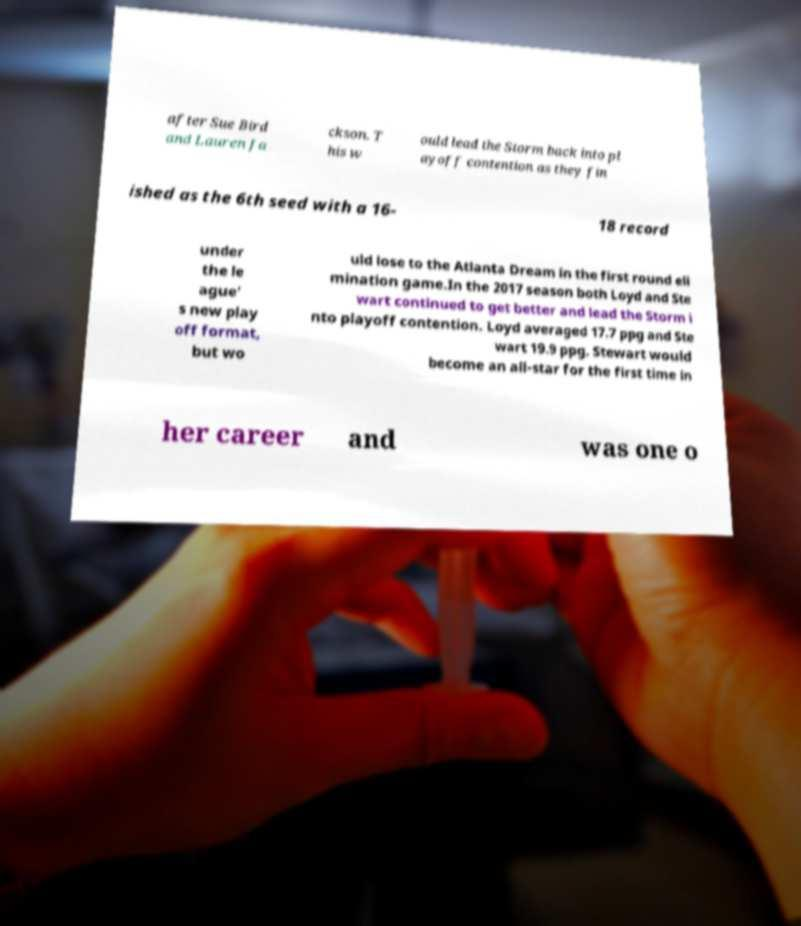Please read and relay the text visible in this image. What does it say? after Sue Bird and Lauren Ja ckson. T his w ould lead the Storm back into pl ayoff contention as they fin ished as the 6th seed with a 16- 18 record under the le ague' s new play off format, but wo uld lose to the Atlanta Dream in the first round eli mination game.In the 2017 season both Loyd and Ste wart continued to get better and lead the Storm i nto playoff contention. Loyd averaged 17.7 ppg and Ste wart 19.9 ppg. Stewart would become an all-star for the first time in her career and was one o 